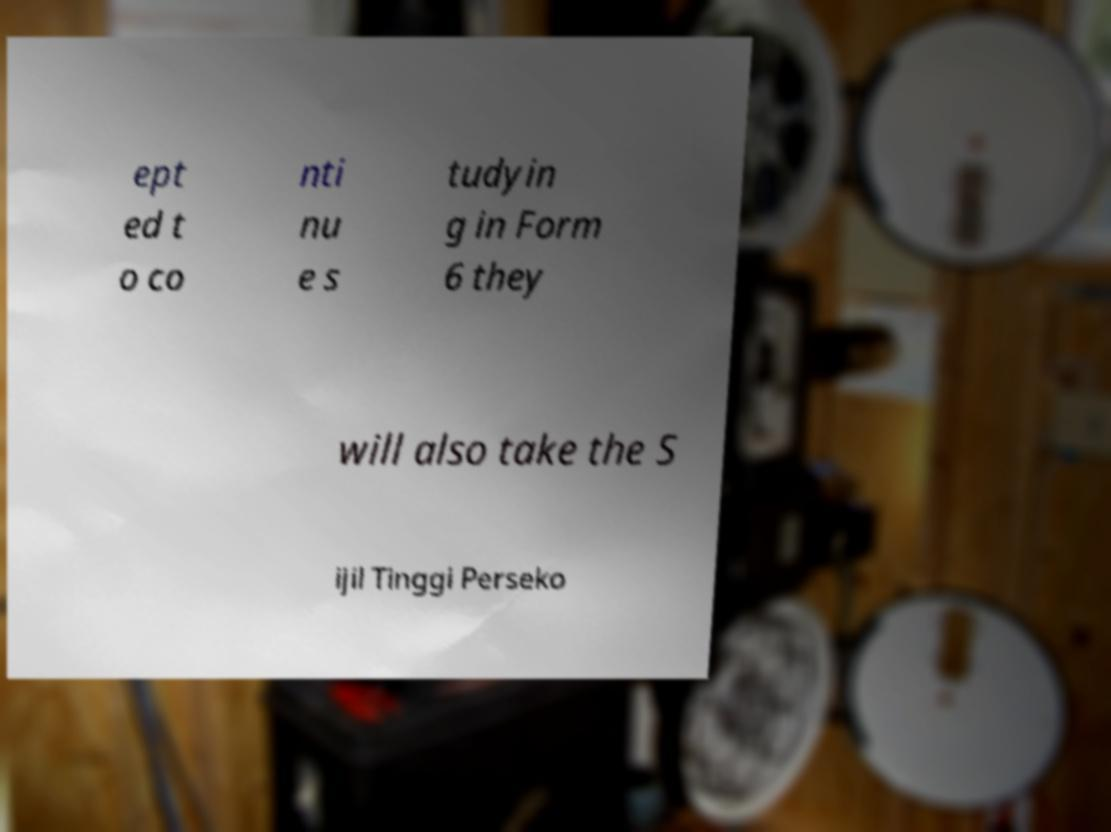There's text embedded in this image that I need extracted. Can you transcribe it verbatim? ept ed t o co nti nu e s tudyin g in Form 6 they will also take the S ijil Tinggi Perseko 